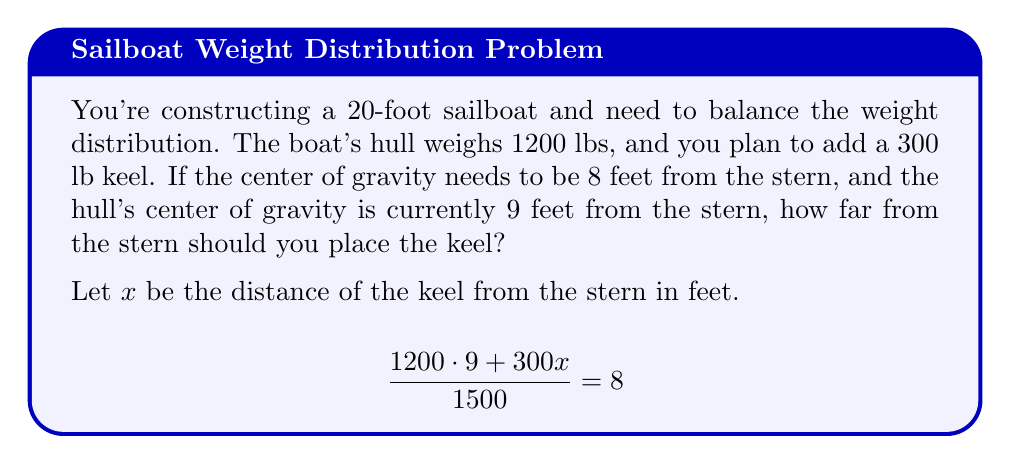Can you answer this question? 1) We use the center of mass formula: 
   $$\frac{m_1x_1 + m_2x_2}{m_1 + m_2} = x_{cm}$$

2) Substituting known values:
   $$\frac{1200 \cdot 9 + 300x}{1200 + 300} = 8$$

3) Simplify the denominator:
   $$\frac{1200 \cdot 9 + 300x}{1500} = 8$$

4) Multiply both sides by 1500:
   $$1200 \cdot 9 + 300x = 8 \cdot 1500$$

5) Simplify the right side:
   $$10800 + 300x = 12000$$

6) Subtract 10800 from both sides:
   $$300x = 1200$$

7) Divide both sides by 300:
   $$x = 4$$

Therefore, the keel should be placed 4 feet from the stern to achieve the desired center of gravity.
Answer: 4 feet 